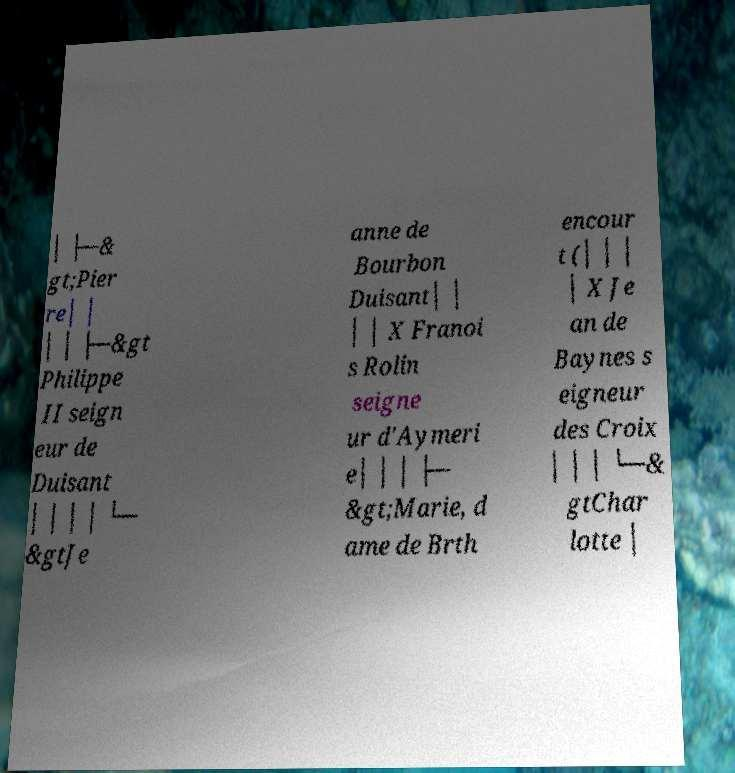I need the written content from this picture converted into text. Can you do that? │ ├─& gt;Pier re│ │ │ │ ├─&gt Philippe II seign eur de Duisant │ │ │ │ └─ &gtJe anne de Bourbon Duisant│ │ │ │ X Franoi s Rolin seigne ur d'Aymeri e│ │ │ ├─ &gt;Marie, d ame de Brth encour t (│ │ │ │ X Je an de Baynes s eigneur des Croix │ │ │ └─& gtChar lotte │ 